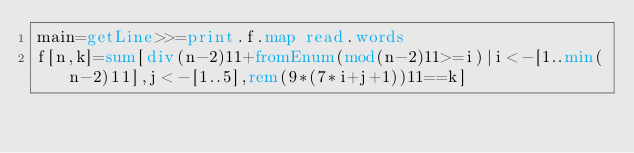Convert code to text. <code><loc_0><loc_0><loc_500><loc_500><_Haskell_>main=getLine>>=print.f.map read.words
f[n,k]=sum[div(n-2)11+fromEnum(mod(n-2)11>=i)|i<-[1..min(n-2)11],j<-[1..5],rem(9*(7*i+j+1))11==k]
</code> 